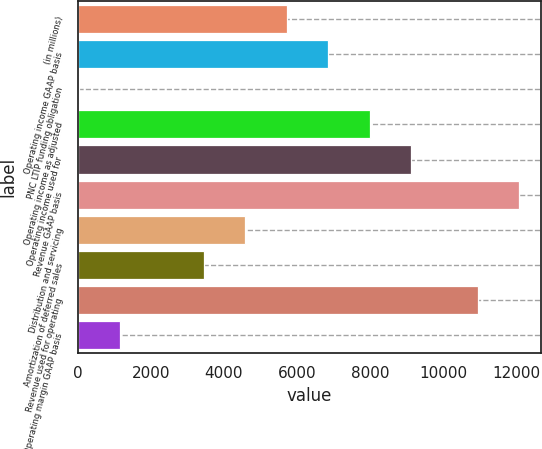Convert chart. <chart><loc_0><loc_0><loc_500><loc_500><bar_chart><fcel>(in millions)<fcel>Operating income GAAP basis<fcel>PNC LTIP funding obligation<fcel>Operating income as adjusted<fcel>Operating income used for<fcel>Revenue GAAP basis<fcel>Distribution and servicing<fcel>Amortization of deferred sales<fcel>Revenue used for operating<fcel>Operating margin GAAP basis<nl><fcel>5715.5<fcel>6852.6<fcel>30<fcel>7989.7<fcel>9126.8<fcel>12081.1<fcel>4578.4<fcel>3441.3<fcel>10944<fcel>1167.1<nl></chart> 